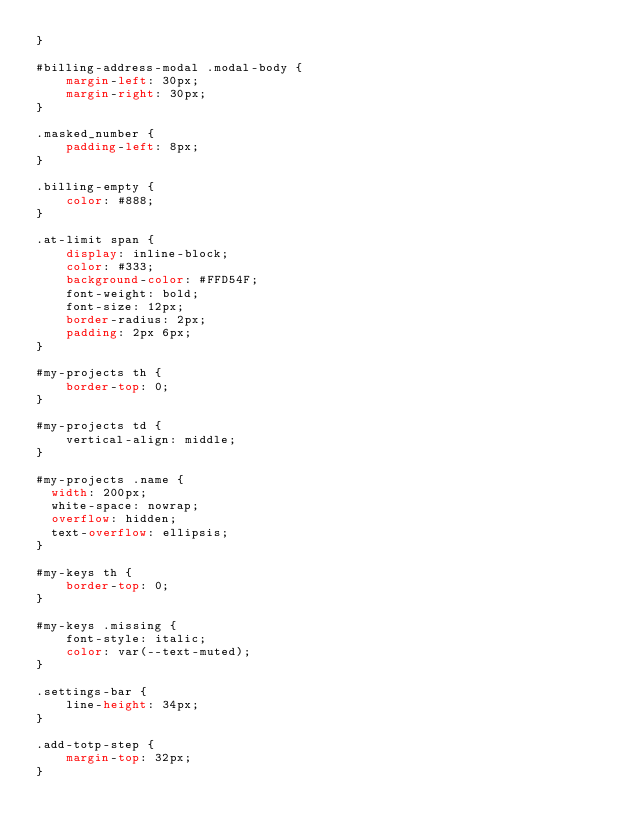Convert code to text. <code><loc_0><loc_0><loc_500><loc_500><_CSS_>}

#billing-address-modal .modal-body {
    margin-left: 30px;
    margin-right: 30px;
}

.masked_number {
    padding-left: 8px;
}

.billing-empty {
    color: #888;
}

.at-limit span {
    display: inline-block;
    color: #333;
    background-color: #FFD54F;
    font-weight: bold;
    font-size: 12px;
    border-radius: 2px;
    padding: 2px 6px;
}

#my-projects th {
    border-top: 0;
}

#my-projects td {
    vertical-align: middle;
}

#my-projects .name {
  width: 200px;
  white-space: nowrap;
  overflow: hidden;
  text-overflow: ellipsis;
}

#my-keys th {
    border-top: 0;
}

#my-keys .missing {
    font-style: italic;
    color: var(--text-muted);
}

.settings-bar {
    line-height: 34px;
}

.add-totp-step {
    margin-top: 32px;
}</code> 